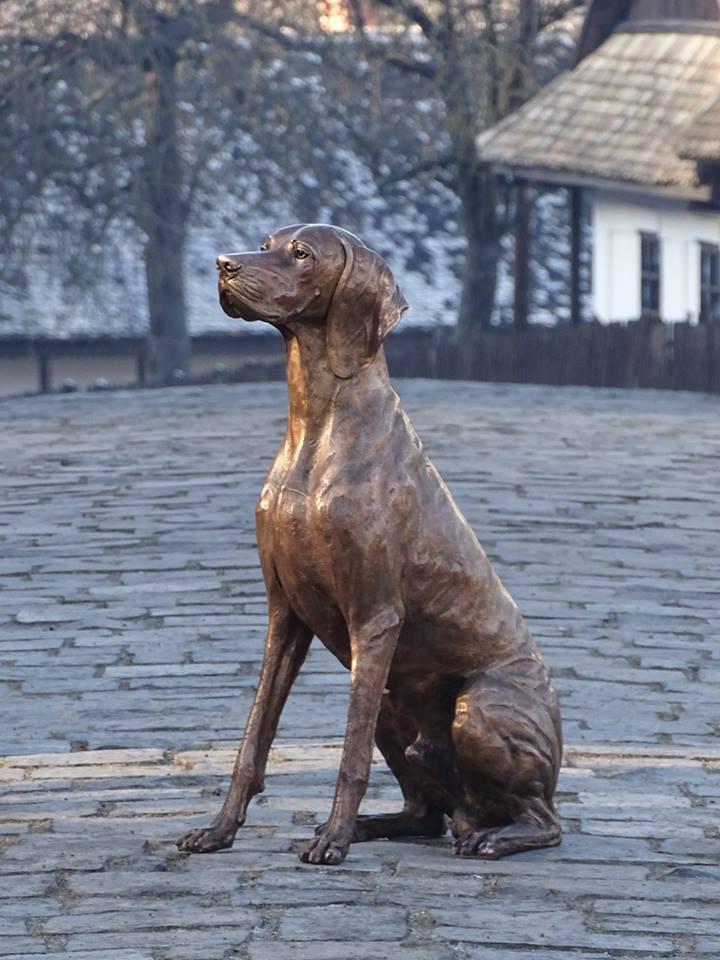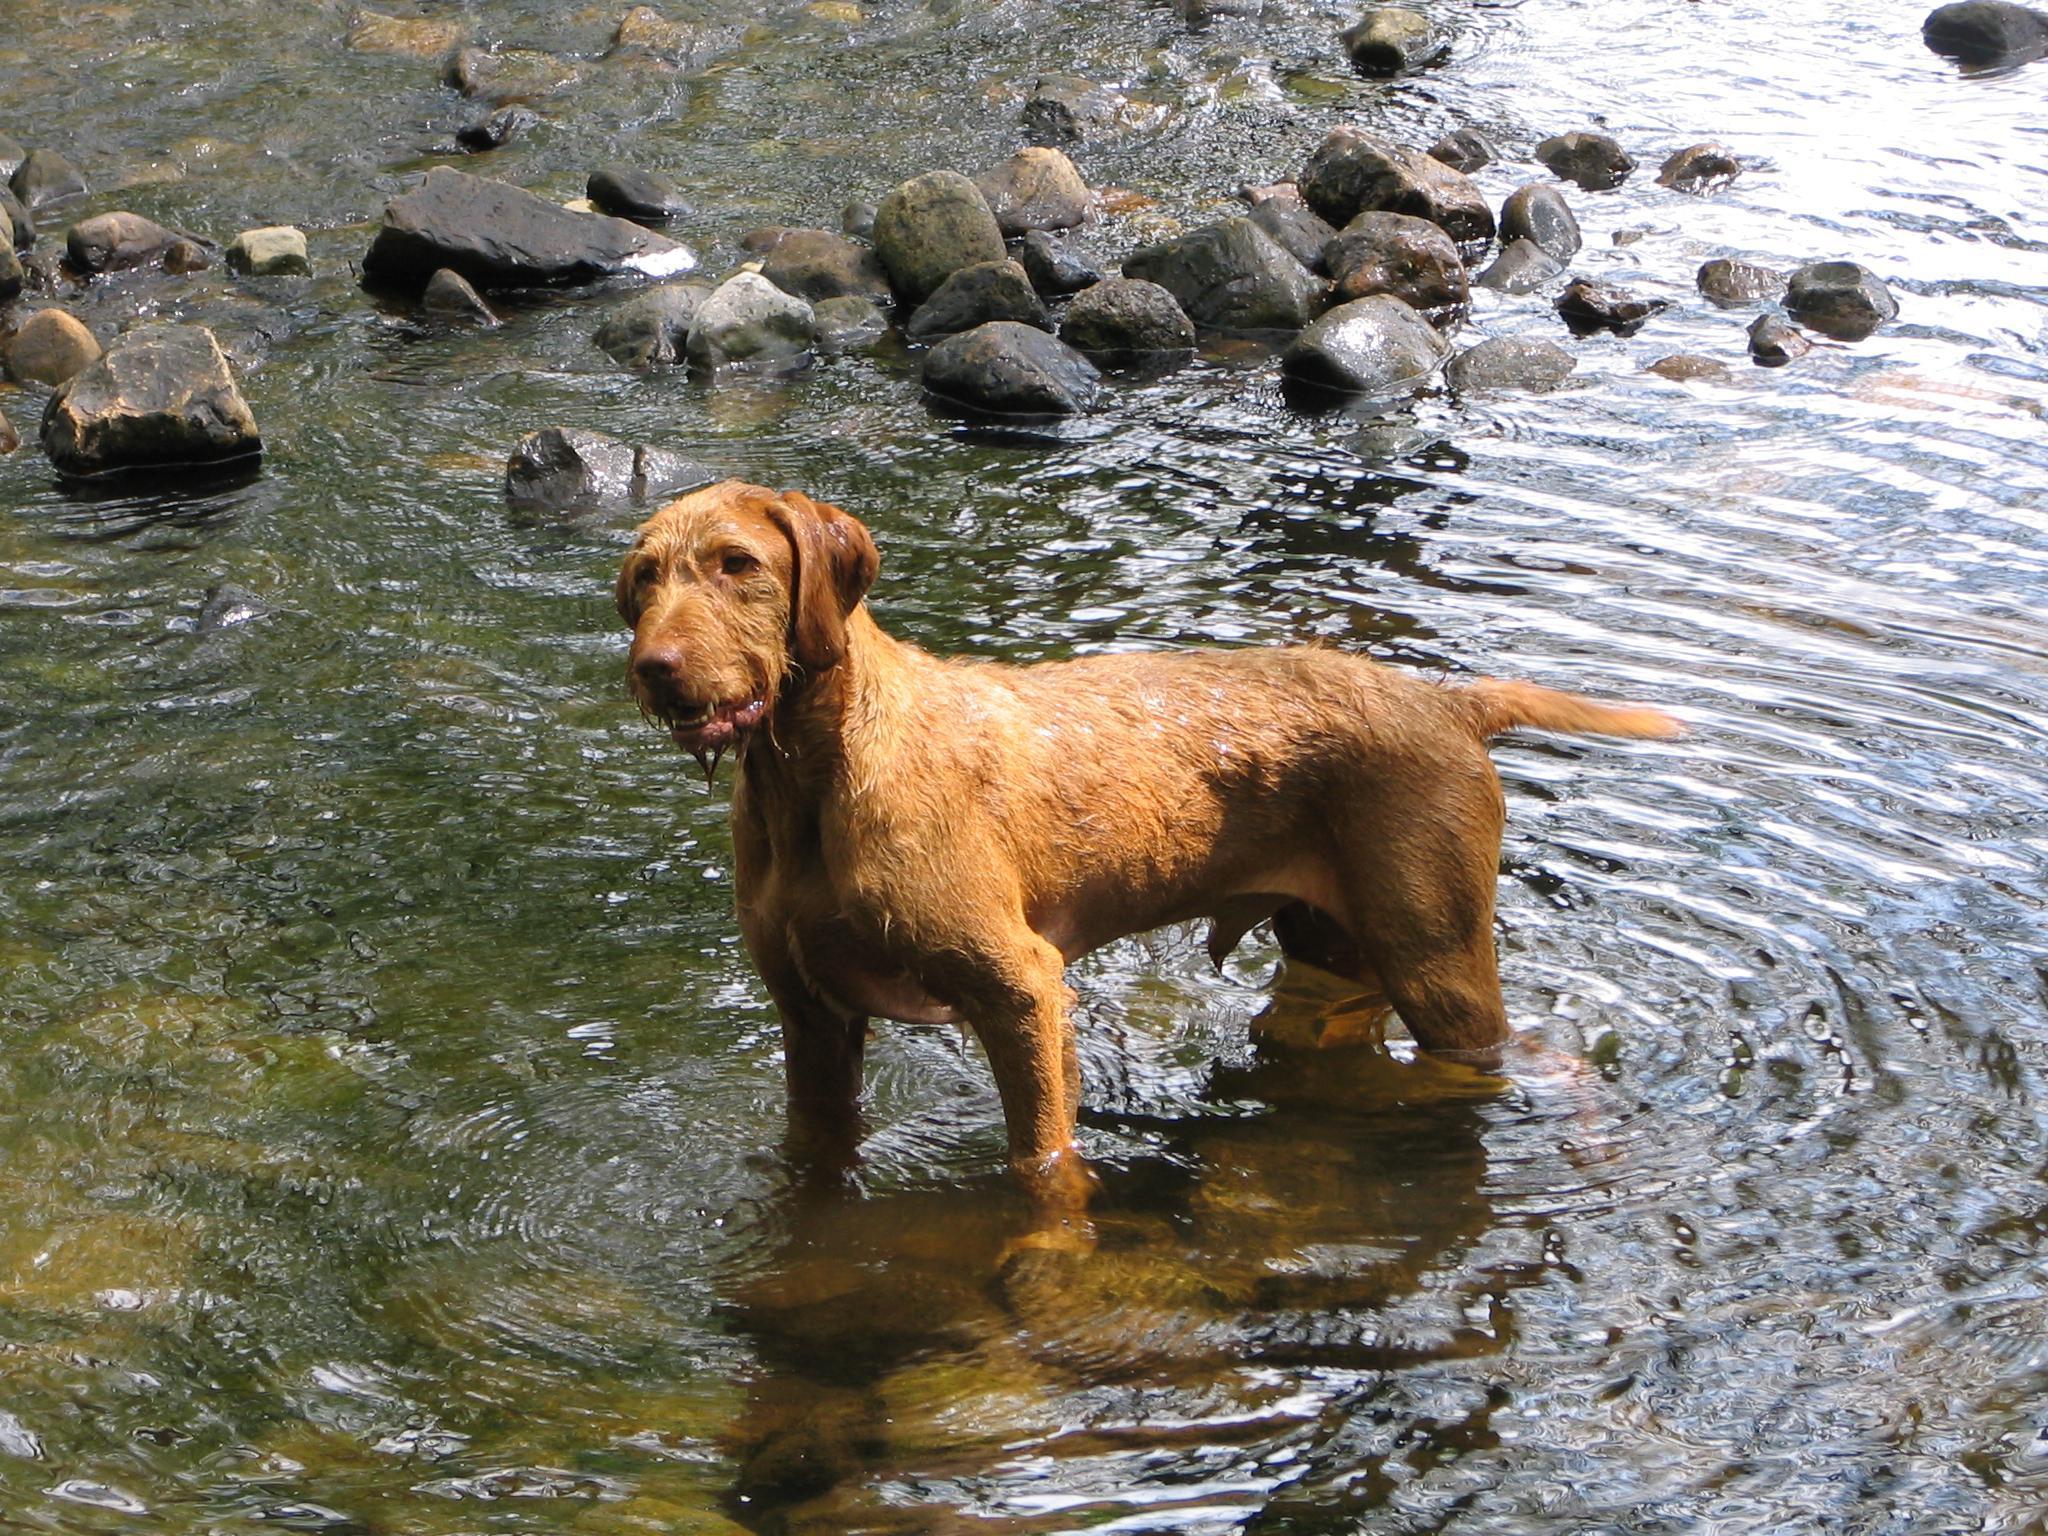The first image is the image on the left, the second image is the image on the right. Examine the images to the left and right. Is the description "Exactly one dog is standing in water." accurate? Answer yes or no. Yes. The first image is the image on the left, the second image is the image on the right. For the images shown, is this caption "In the left image there is a brown dog sitting on the ground." true? Answer yes or no. Yes. 